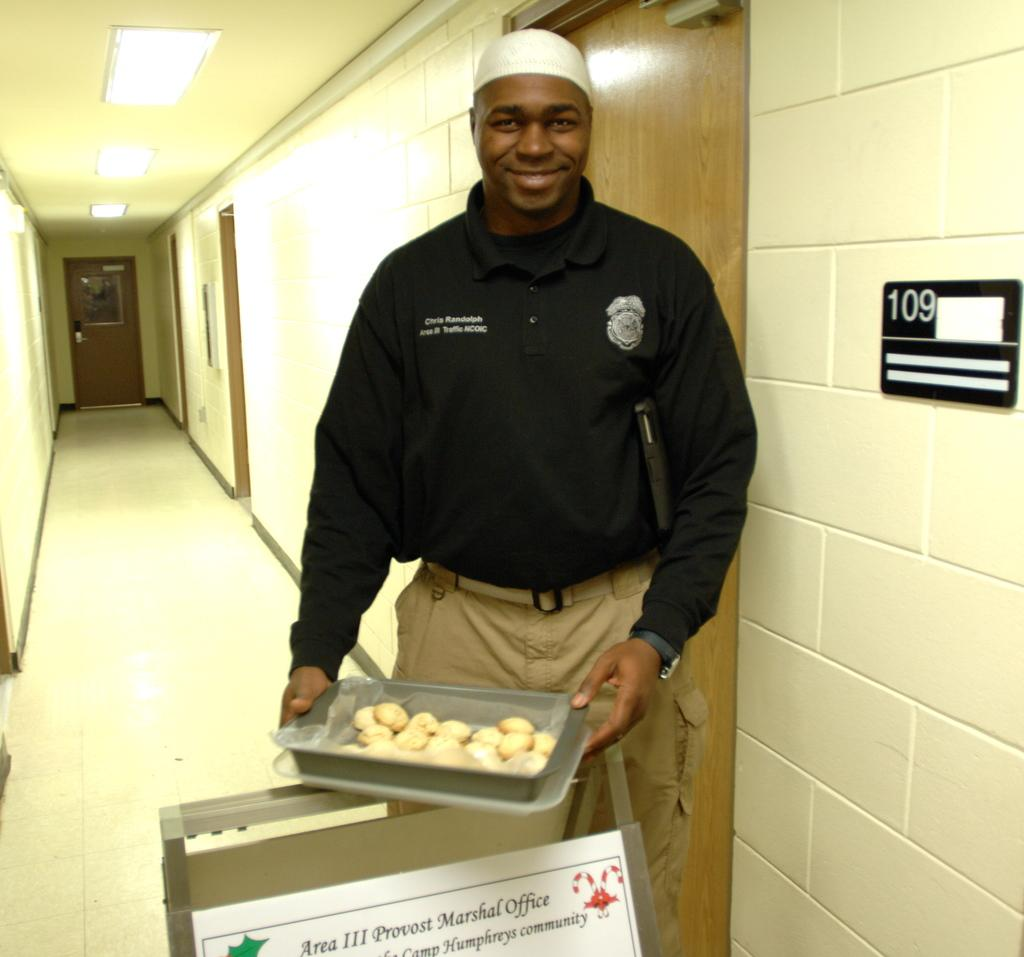What is the person in the image holding? The person is holding a tray in the image. What can be seen behind the person? There is a wall in the image. What is located on the side of the image? There is a small blackboard on the side in the image. What architectural feature is visible in the background? There is a door in the background of the image. What is on top of the area where the person is standing? There is a roof with lights in the image. What type of bead is being used to sweeten the team's drinks in the image? There is no bead or team present in the image, and no drinks are mentioned. 